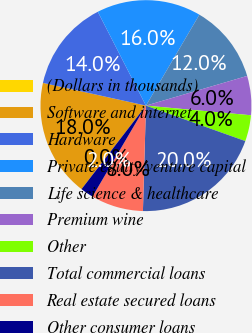<chart> <loc_0><loc_0><loc_500><loc_500><pie_chart><fcel>(Dollars in thousands)<fcel>Software and internet<fcel>Hardware<fcel>Private equity/venture capital<fcel>Life science & healthcare<fcel>Premium wine<fcel>Other<fcel>Total commercial loans<fcel>Real estate secured loans<fcel>Other consumer loans<nl><fcel>0.0%<fcel>18.0%<fcel>14.0%<fcel>16.0%<fcel>12.0%<fcel>6.0%<fcel>4.0%<fcel>20.0%<fcel>8.0%<fcel>2.0%<nl></chart> 